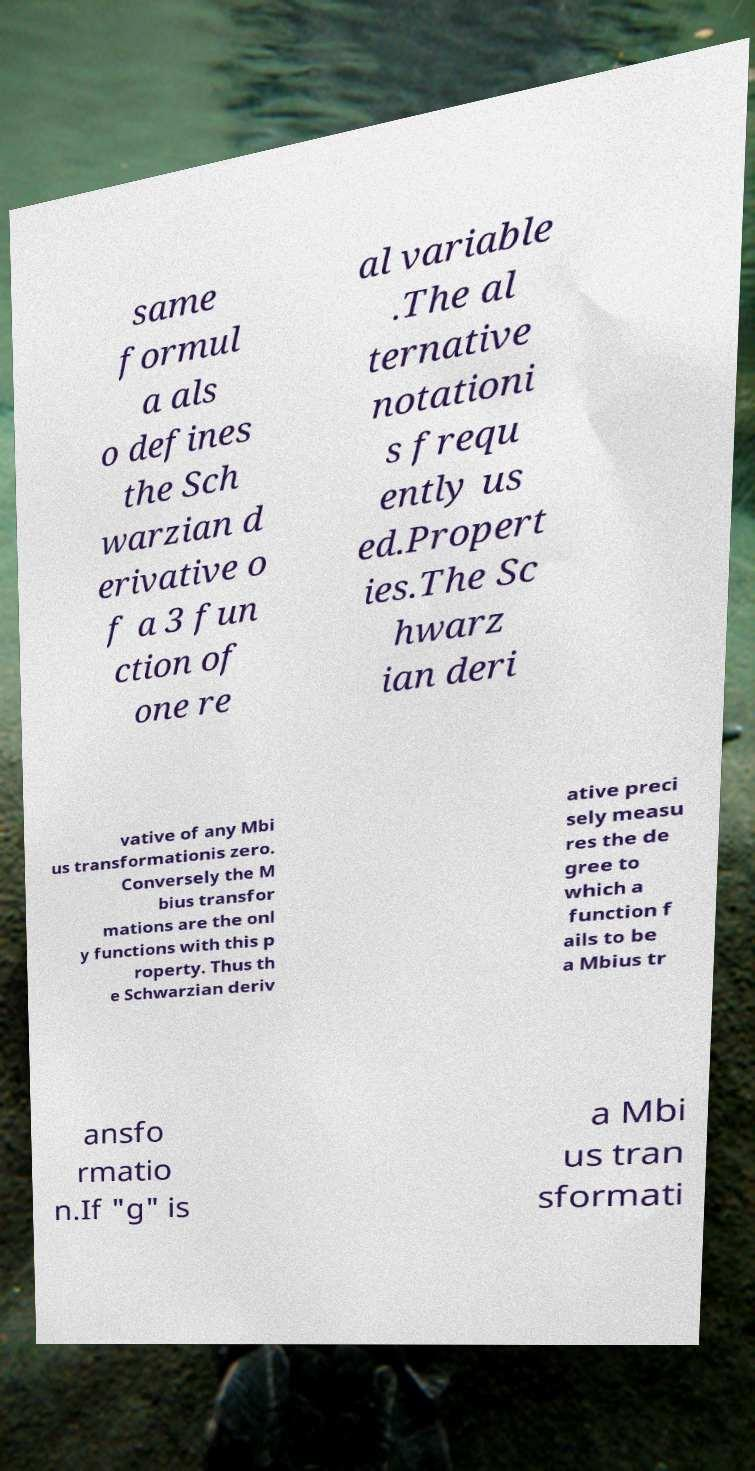Can you accurately transcribe the text from the provided image for me? same formul a als o defines the Sch warzian d erivative o f a 3 fun ction of one re al variable .The al ternative notationi s frequ ently us ed.Propert ies.The Sc hwarz ian deri vative of any Mbi us transformationis zero. Conversely the M bius transfor mations are the onl y functions with this p roperty. Thus th e Schwarzian deriv ative preci sely measu res the de gree to which a function f ails to be a Mbius tr ansfo rmatio n.If "g" is a Mbi us tran sformati 